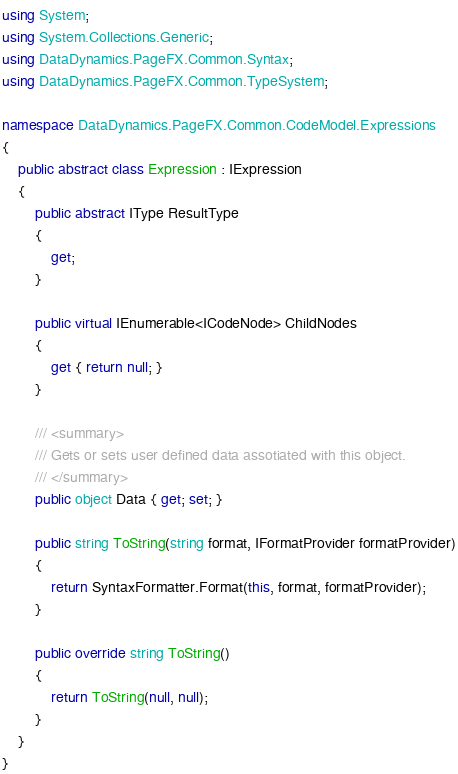<code> <loc_0><loc_0><loc_500><loc_500><_C#_>using System;
using System.Collections.Generic;
using DataDynamics.PageFX.Common.Syntax;
using DataDynamics.PageFX.Common.TypeSystem;

namespace DataDynamics.PageFX.Common.CodeModel.Expressions
{
    public abstract class Expression : IExpression
    {
    	public abstract IType ResultType
        {
            get;
        }

	    public virtual IEnumerable<ICodeNode> ChildNodes
        {
            get { return null; }
        }

    	/// <summary>
    	/// Gets or sets user defined data assotiated with this object.
    	/// </summary>
    	public object Data { get; set; }

    	public string ToString(string format, IFormatProvider formatProvider)
        {
            return SyntaxFormatter.Format(this, format, formatProvider);
        }

    	public override string ToString()
        {
            return ToString(null, null);
        }
    }
}</code> 